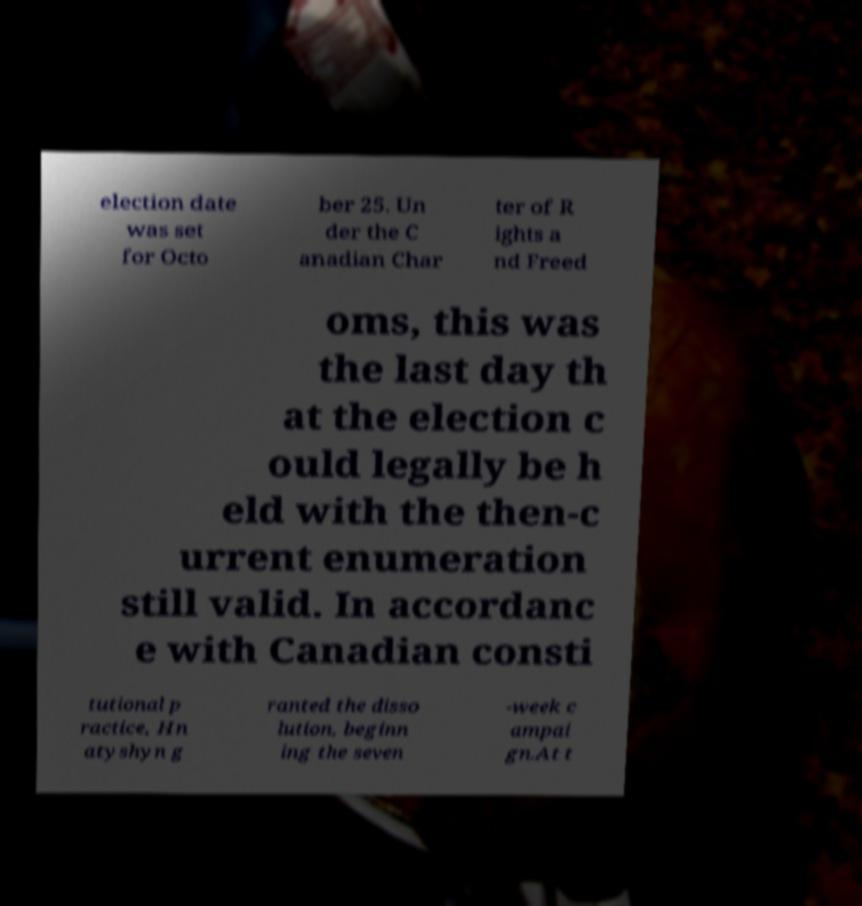Please read and relay the text visible in this image. What does it say? election date was set for Octo ber 25. Un der the C anadian Char ter of R ights a nd Freed oms, this was the last day th at the election c ould legally be h eld with the then-c urrent enumeration still valid. In accordanc e with Canadian consti tutional p ractice, Hn atyshyn g ranted the disso lution, beginn ing the seven -week c ampai gn.At t 